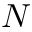Convert formula to latex. <formula><loc_0><loc_0><loc_500><loc_500>N</formula> 